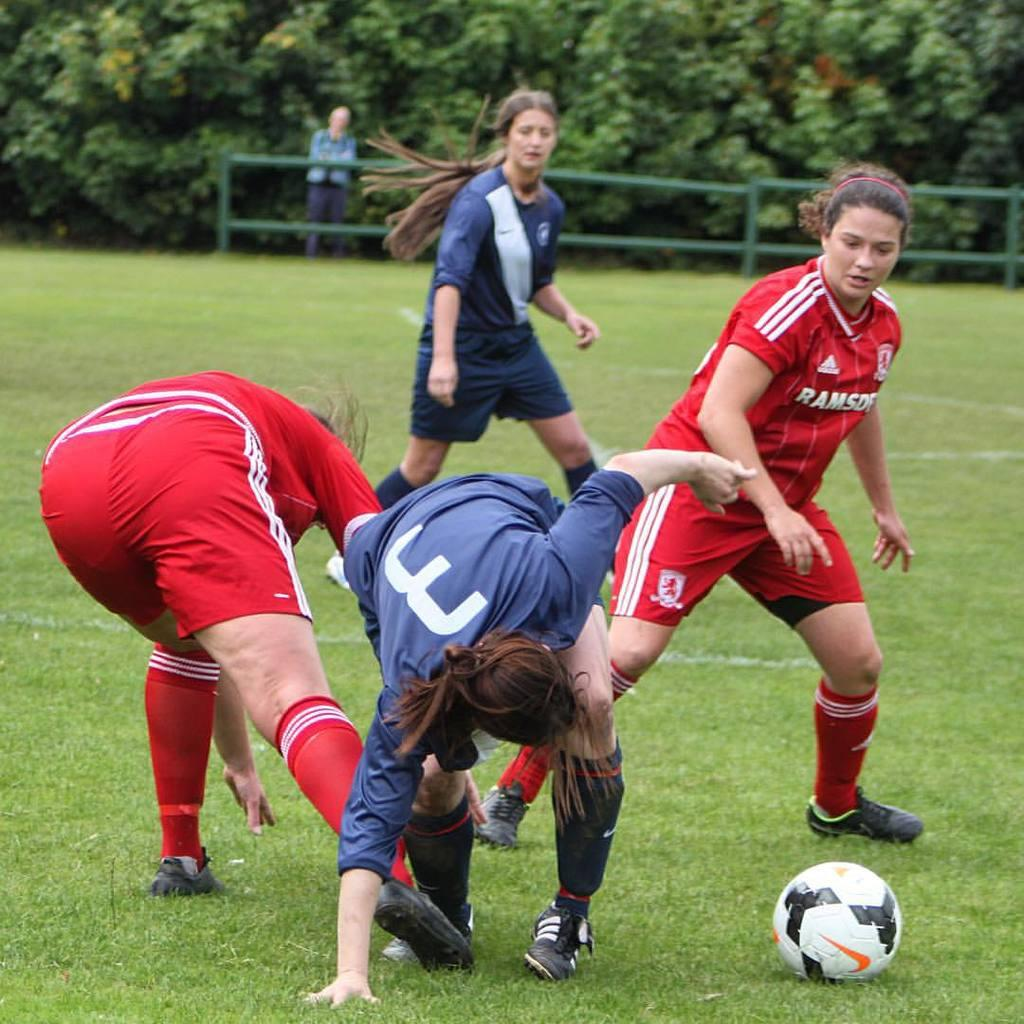<image>
Render a clear and concise summary of the photo. Several women play sports; one of them has the number 3 on their shirt. 